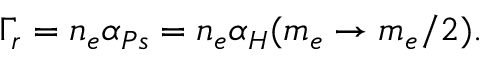<formula> <loc_0><loc_0><loc_500><loc_500>\Gamma _ { r } = n _ { e } \alpha _ { P s } = n _ { e } \alpha _ { H } ( m _ { e } \rightarrow m _ { e } / 2 ) .</formula> 